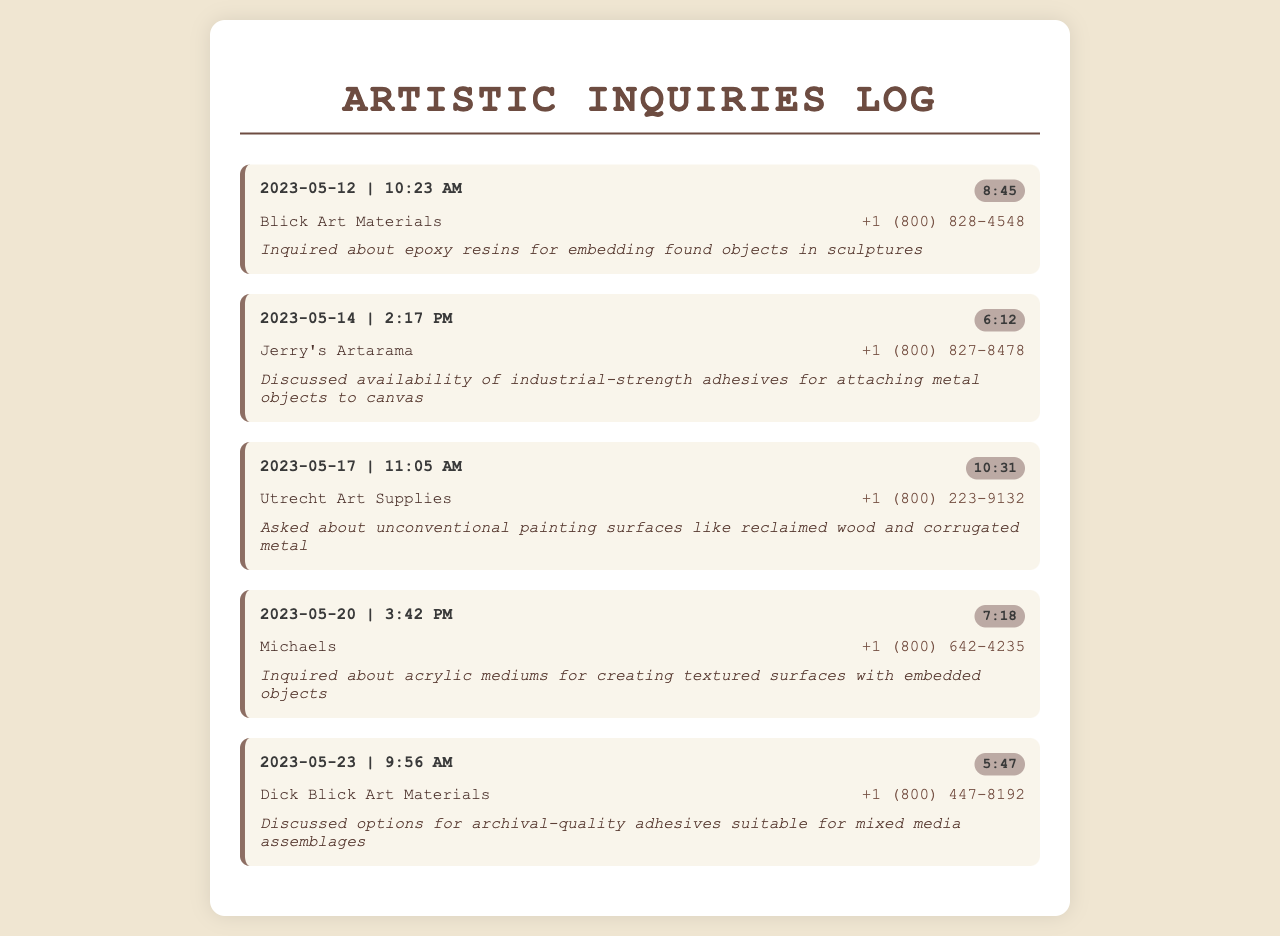What is the date of the first call? The date of the first call is found in the first record of the document, which is 2023-05-12.
Answer: 2023-05-12 Who did the artist call on May 14? The artist called Jerry's Artarama on May 14 as indicated in that entry.
Answer: Jerry's Artarama What was the duration of the call to Blick Art Materials? The duration of the call can be seen in the first record, which states 8:45.
Answer: 8:45 What type of adhesives did the artist inquire about during the call on May 17? The artist discussed industrial-strength adhesives for a specific application during the second call, which is about attaching metal objects to canvas.
Answer: Industrial-strength adhesives What unique surfaces was the artist interested in from Utrecht Art Supplies? The artist asked about unconventional painting surfaces during the call, as detailed in the third record.
Answer: Reclaimed wood and corrugated metal How many calls were made to Dick Blick Art Materials? Only one call is noted in the document to Dick Blick Art Materials on May 23.
Answer: One What is the main focus of the artist’s inquiries? The artist primarily asked about non-traditional mediums and adhesives for their mixed media pieces, as seen throughout the records.
Answer: Non-traditional mediums and adhesives What phone number was called for inquiries on May 20? The phone number is listed in the fourth record under Michaels' contact information.
Answer: +1 (800) 642-4235 What did the artist ask about during the call on May 23? The document states that the artist discussed archival-quality adhesives suitable for mixed media assemblages during that call.
Answer: Archival-quality adhesives 